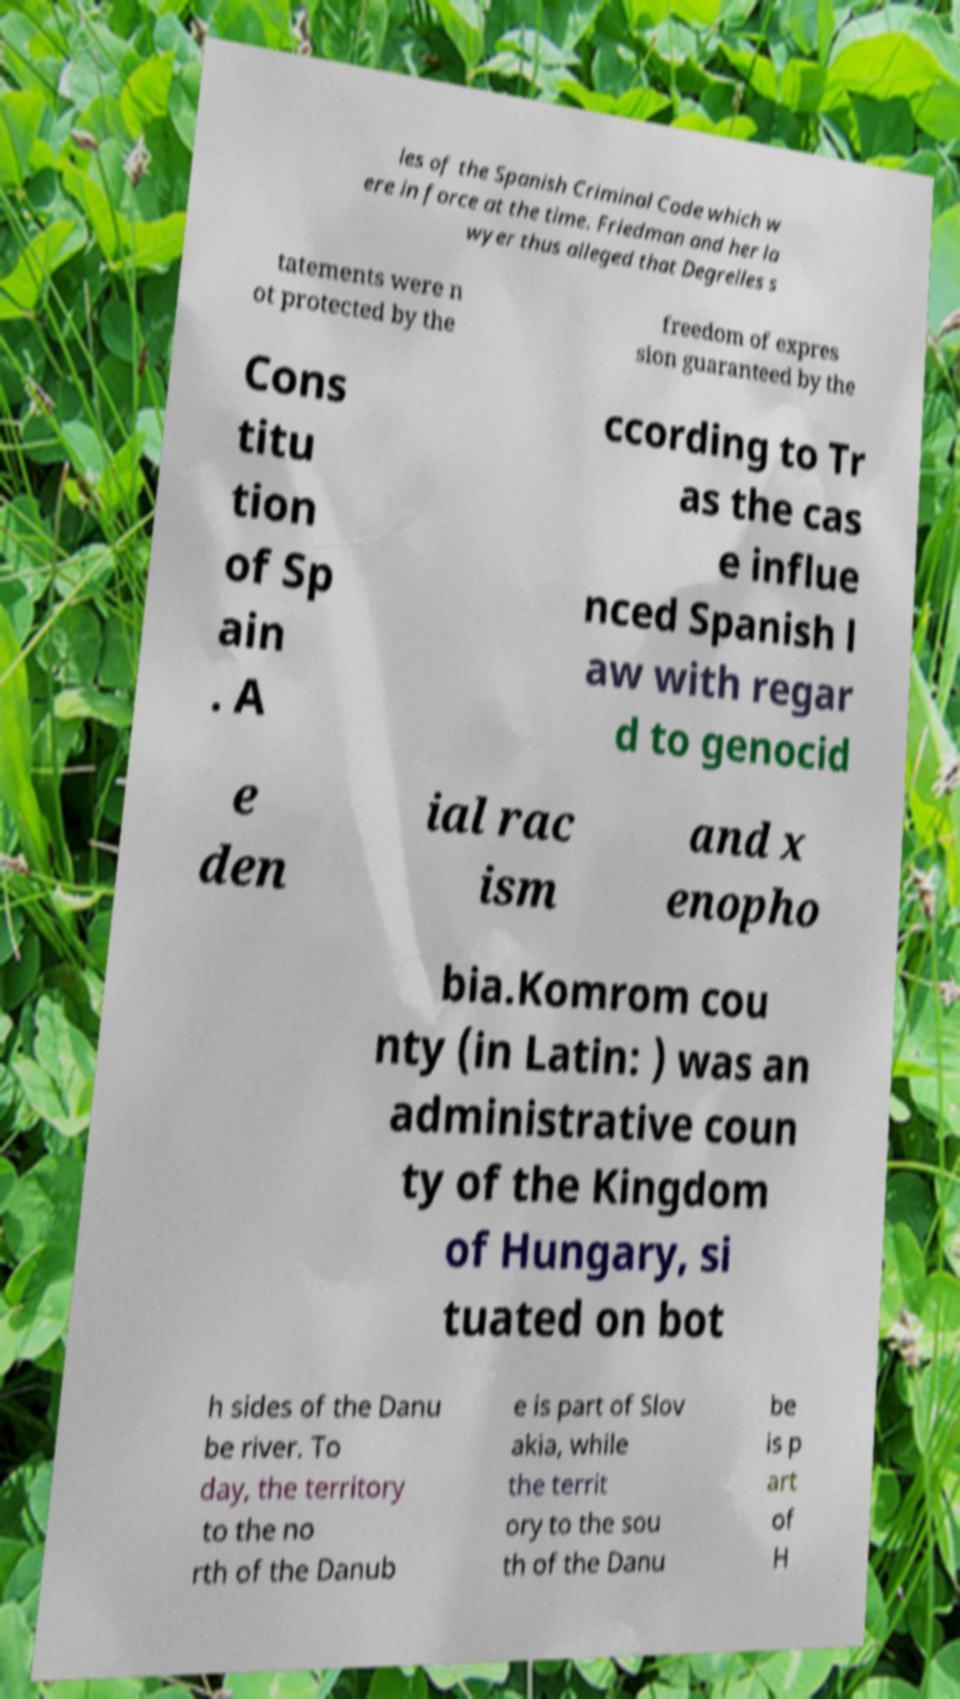For documentation purposes, I need the text within this image transcribed. Could you provide that? les of the Spanish Criminal Code which w ere in force at the time. Friedman and her la wyer thus alleged that Degrelles s tatements were n ot protected by the freedom of expres sion guaranteed by the Cons titu tion of Sp ain . A ccording to Tr as the cas e influe nced Spanish l aw with regar d to genocid e den ial rac ism and x enopho bia.Komrom cou nty (in Latin: ) was an administrative coun ty of the Kingdom of Hungary, si tuated on bot h sides of the Danu be river. To day, the territory to the no rth of the Danub e is part of Slov akia, while the territ ory to the sou th of the Danu be is p art of H 